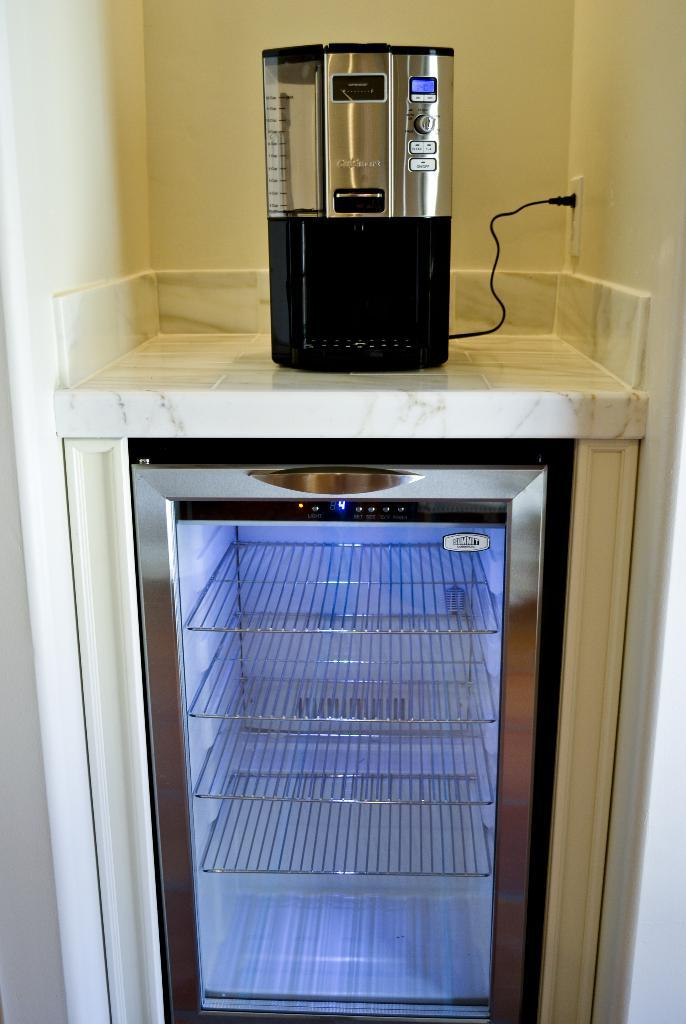What can be seen in the image? There are machines in the image. What is visible in the background of the image? There is a wall in the background of the image. Can you describe the wall in the image? The wall has a socket. What type of steel is used to make the mark on the window in the image? There is no steel, mark, or window present in the image. 